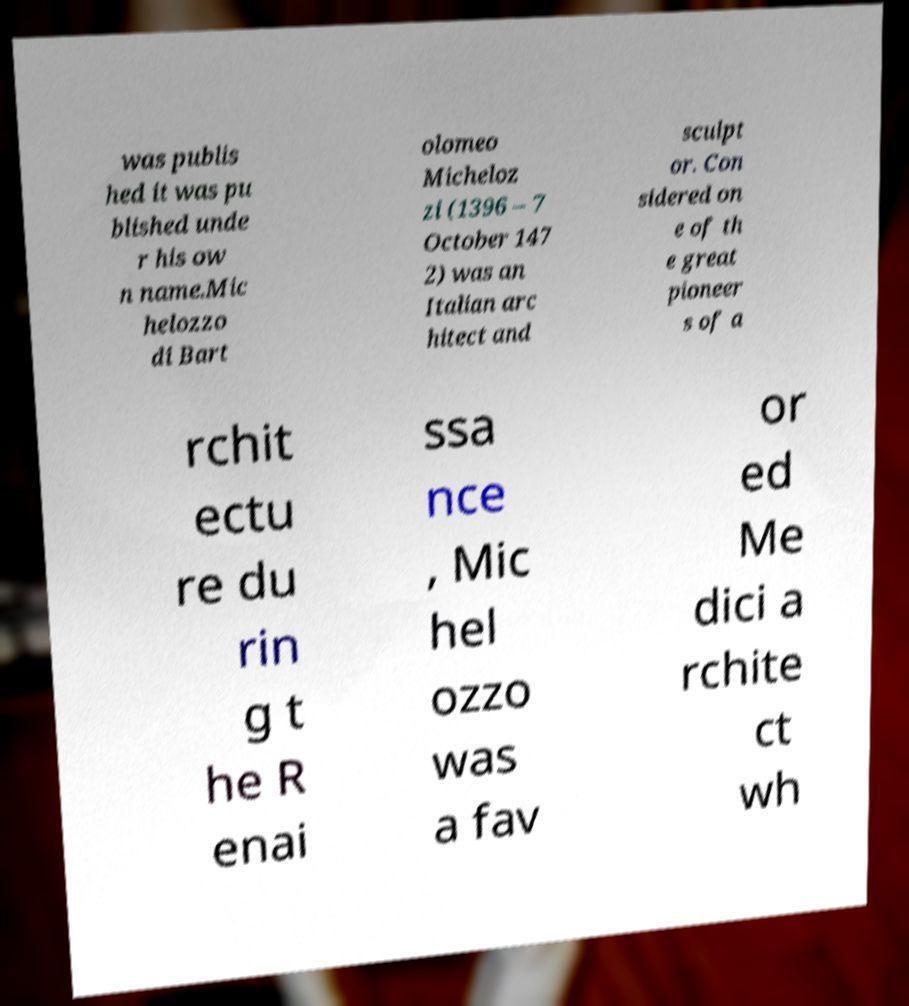Can you accurately transcribe the text from the provided image for me? was publis hed it was pu blished unde r his ow n name.Mic helozzo di Bart olomeo Micheloz zi (1396 – 7 October 147 2) was an Italian arc hitect and sculpt or. Con sidered on e of th e great pioneer s of a rchit ectu re du rin g t he R enai ssa nce , Mic hel ozzo was a fav or ed Me dici a rchite ct wh 